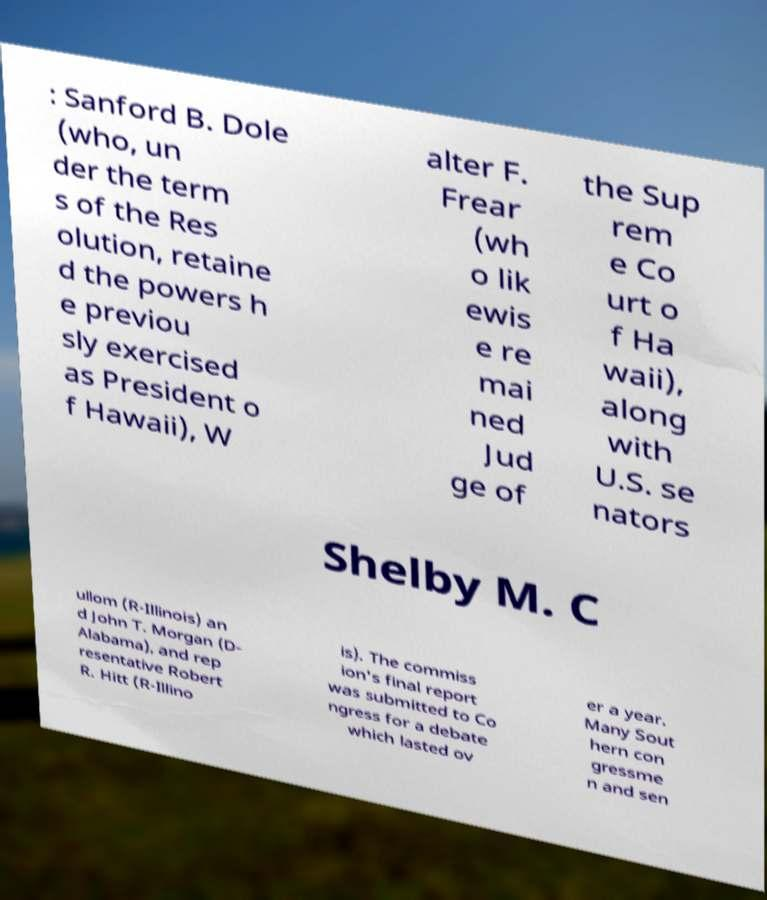For documentation purposes, I need the text within this image transcribed. Could you provide that? : Sanford B. Dole (who, un der the term s of the Res olution, retaine d the powers h e previou sly exercised as President o f Hawaii), W alter F. Frear (wh o lik ewis e re mai ned Jud ge of the Sup rem e Co urt o f Ha waii), along with U.S. se nators Shelby M. C ullom (R-Illinois) an d John T. Morgan (D- Alabama), and rep resentative Robert R. Hitt (R-Illino is). The commiss ion's final report was submitted to Co ngress for a debate which lasted ov er a year. Many Sout hern con gressme n and sen 